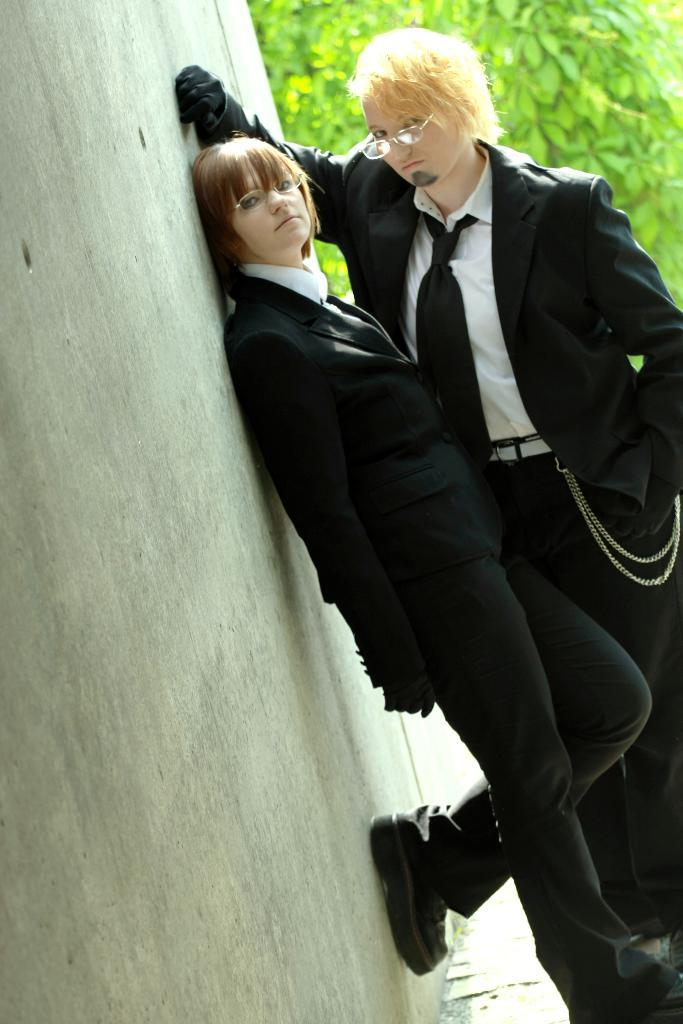How many people are in the image? There are two persons in the image. What else can be seen in the image besides the people? There are plants and a wall in the image. What type of bomb is being defused by the minister in the image? There is no bomb or minister present in the image; it features two persons and plants. 